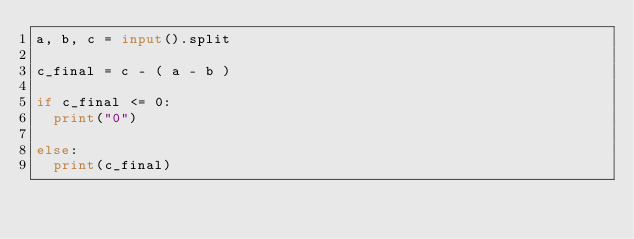<code> <loc_0><loc_0><loc_500><loc_500><_Python_>a, b, c = input().split

c_final = c - ( a - b )

if c_final <= 0:
  print("0")
  
else:
  print(c_final)</code> 